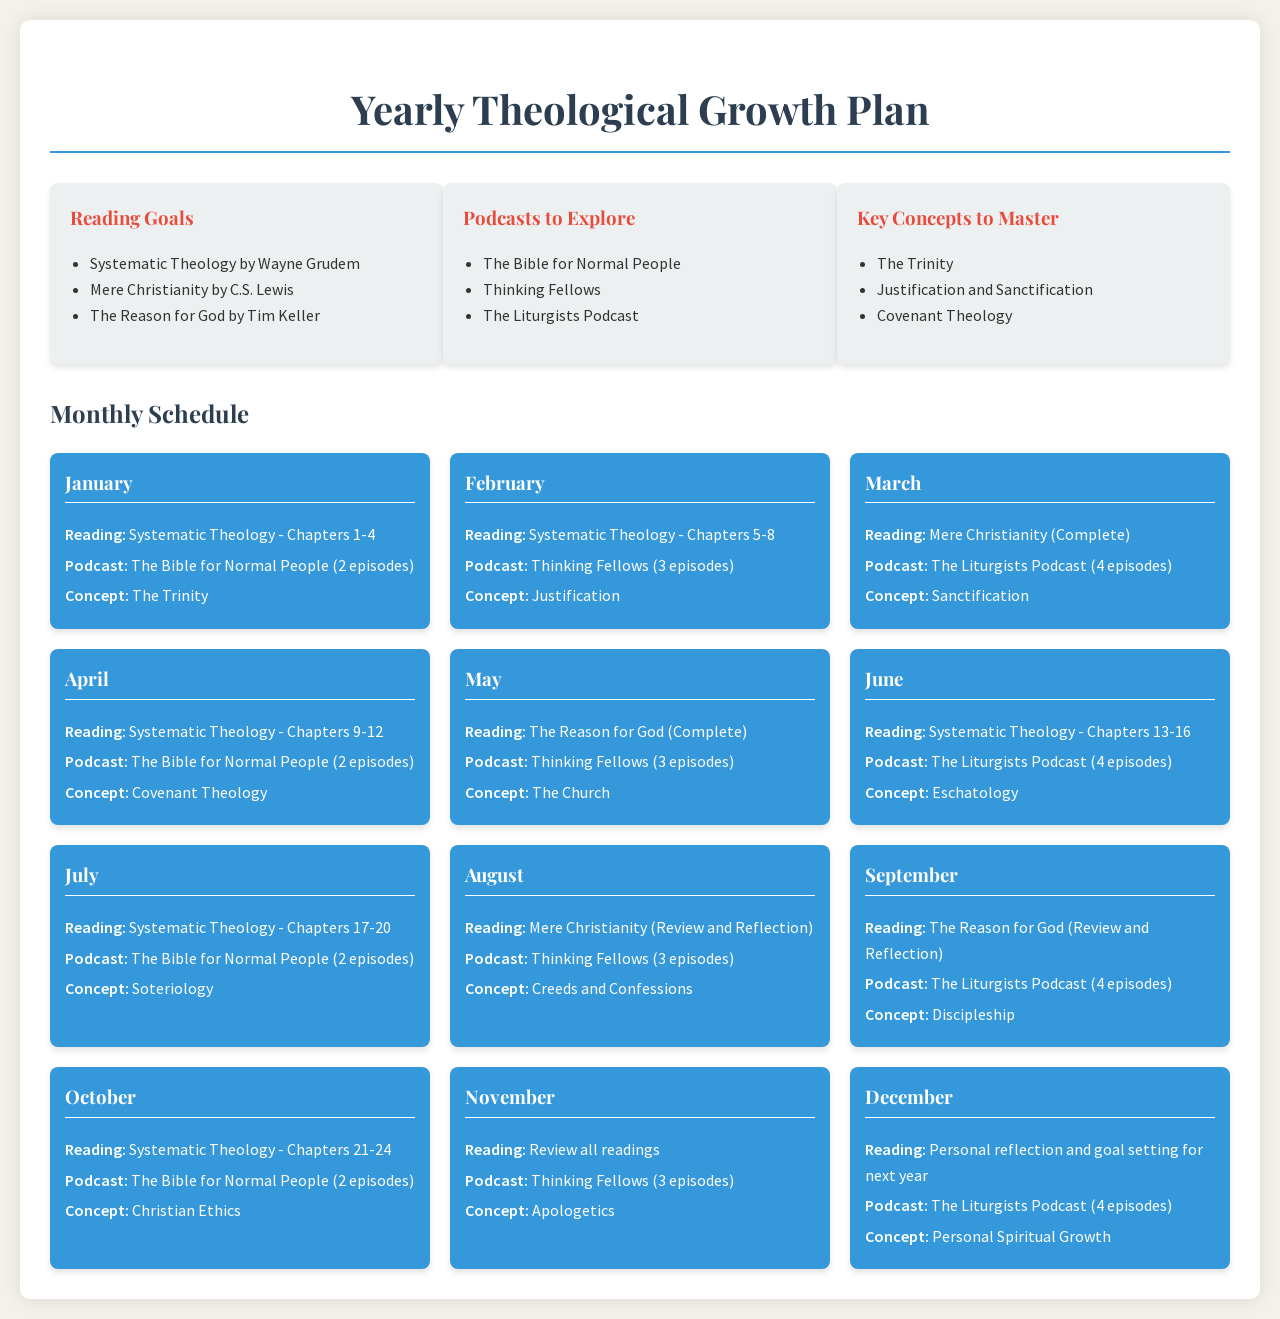What book is recommended for January reading? The recommended reading for January is specified in the schedule, which lists the chapters to be covered.
Answer: Systematic Theology - Chapters 1-4 How many episodes of The Liturgists Podcast are suggested for March? The schedule outlines the number of podcast episodes for each month, particularly for March.
Answer: 4 episodes What key concept is to be mastered in February? The concept designated for February can be found in the schedule next to the respective month's activities.
Answer: Justification Which book is listed for May's reading? The reading goal for May is noted in the monthly schedule alongside the other activities planned for that month.
Answer: The Reason for God (Complete) What is the focus of the month for December? The activities planned for December, including reading, podcasts, and concepts, are clearly outlined in the schedule for that month.
Answer: Personal reflection and goal setting for next year How many chapters of Systematic Theology are assigned for June? The monthly reading assignments include the chapter ranges to be covered in June.
Answer: Chapters 13-16 What is the total number of podcasts planned for November? The number of podcast episodes for November is indicated in the monthly activities section of the document.
Answer: 3 episodes In which month is the review of Mere Christianity scheduled? The document specifies a review of this book, correlating it with a certain month in the annual plan.
Answer: August 